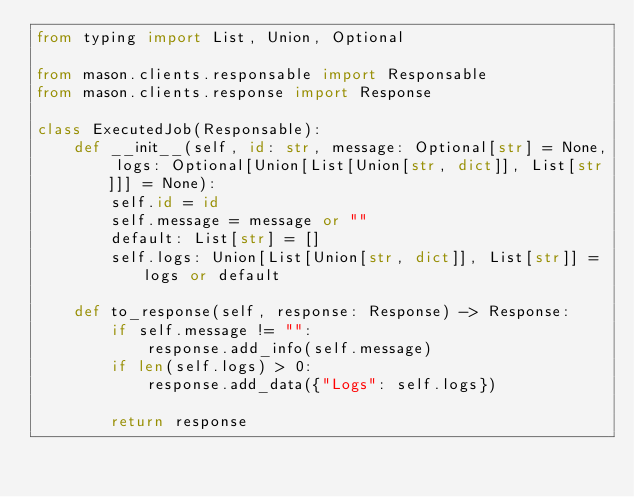<code> <loc_0><loc_0><loc_500><loc_500><_Python_>from typing import List, Union, Optional

from mason.clients.responsable import Responsable
from mason.clients.response import Response

class ExecutedJob(Responsable):
    def __init__(self, id: str, message: Optional[str] = None, logs: Optional[Union[List[Union[str, dict]], List[str]]] = None):
        self.id = id
        self.message = message or ""
        default: List[str] = []
        self.logs: Union[List[Union[str, dict]], List[str]] = logs or default
    
    def to_response(self, response: Response) -> Response:
        if self.message != "":
            response.add_info(self.message)
        if len(self.logs) > 0:
            response.add_data({"Logs": self.logs})
            
        return response
</code> 